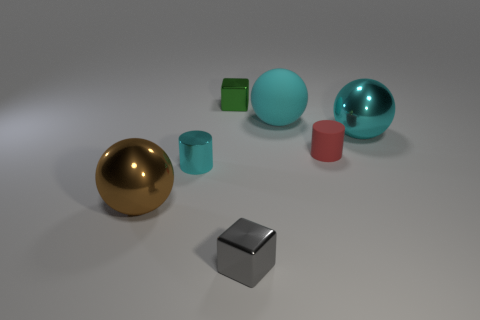Subtract all metal balls. How many balls are left? 1 Add 1 spheres. How many objects exist? 8 Subtract all balls. How many objects are left? 4 Subtract all green cubes. How many cubes are left? 1 Subtract 0 purple cubes. How many objects are left? 7 Subtract 2 cylinders. How many cylinders are left? 0 Subtract all green spheres. Subtract all gray blocks. How many spheres are left? 3 Subtract all brown cubes. How many cyan balls are left? 2 Subtract all large red rubber balls. Subtract all small gray shiny blocks. How many objects are left? 6 Add 5 gray blocks. How many gray blocks are left? 6 